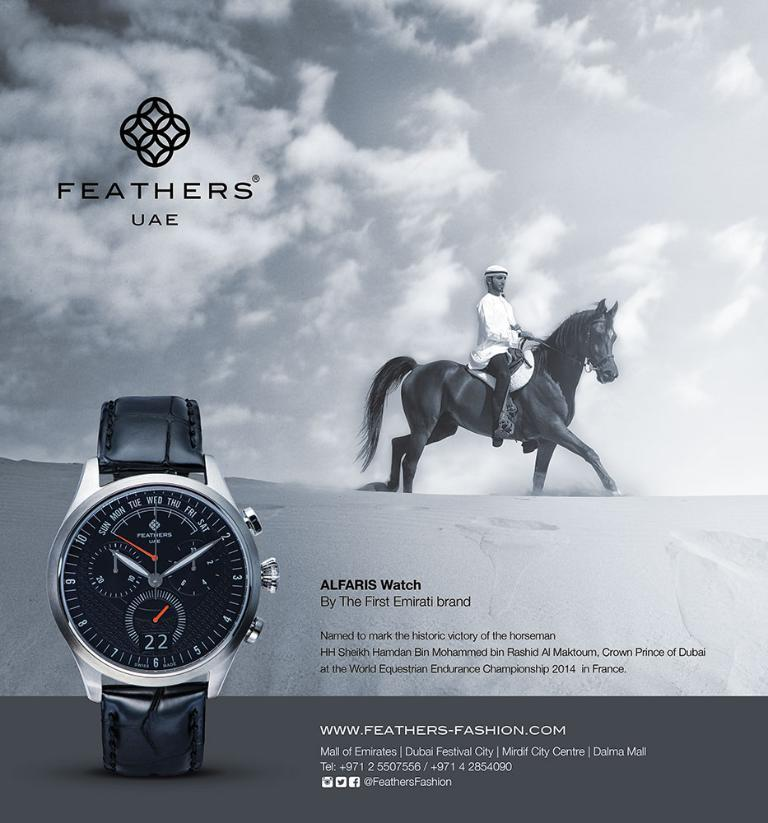<image>
Render a clear and concise summary of the photo. An advert for a feathers branded watch with a man riding a horse on the background. 